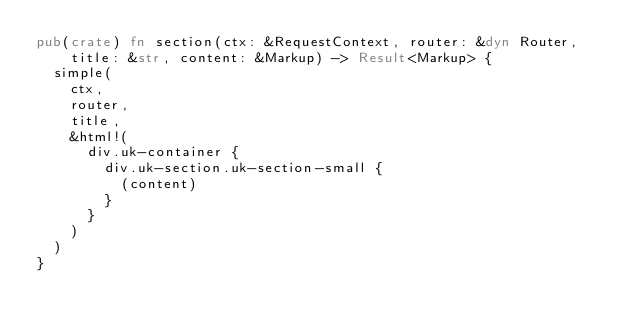Convert code to text. <code><loc_0><loc_0><loc_500><loc_500><_Rust_>pub(crate) fn section(ctx: &RequestContext, router: &dyn Router, title: &str, content: &Markup) -> Result<Markup> {
  simple(
    ctx,
    router,
    title,
    &html!(
      div.uk-container {
        div.uk-section.uk-section-small {
          (content)
        }
      }
    )
  )
}
</code> 